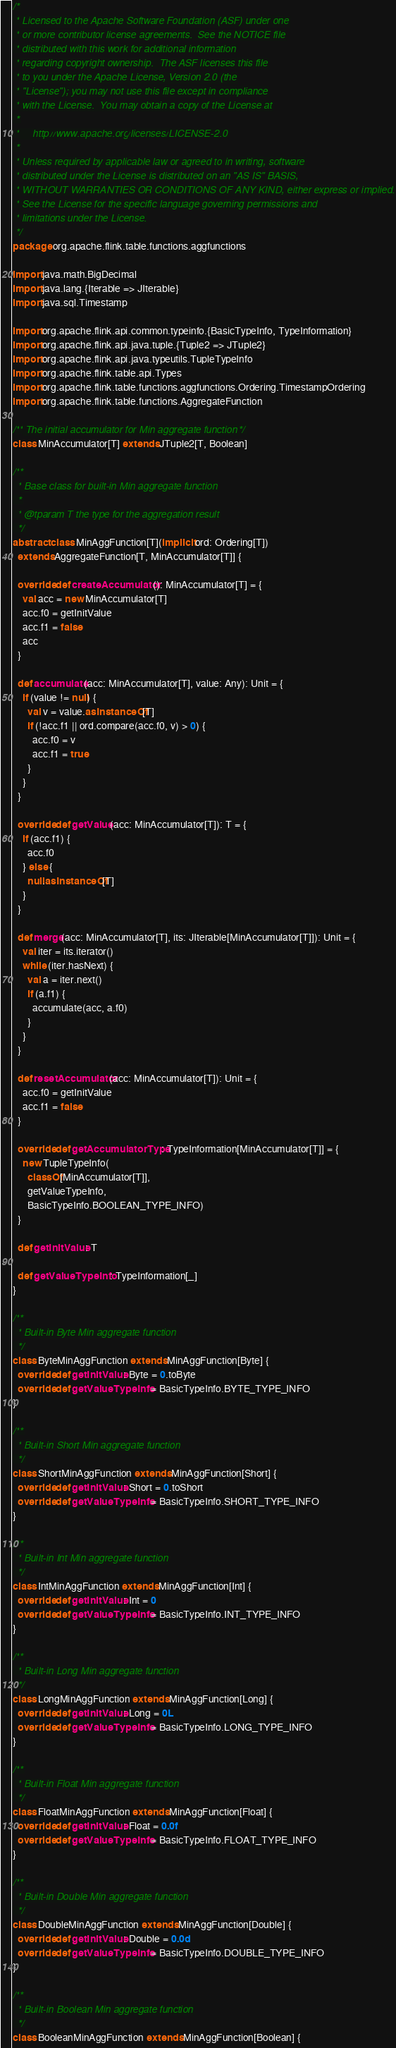Convert code to text. <code><loc_0><loc_0><loc_500><loc_500><_Scala_>/*
 * Licensed to the Apache Software Foundation (ASF) under one
 * or more contributor license agreements.  See the NOTICE file
 * distributed with this work for additional information
 * regarding copyright ownership.  The ASF licenses this file
 * to you under the Apache License, Version 2.0 (the
 * "License"); you may not use this file except in compliance
 * with the License.  You may obtain a copy of the License at
 *
 *     http://www.apache.org/licenses/LICENSE-2.0
 *
 * Unless required by applicable law or agreed to in writing, software
 * distributed under the License is distributed on an "AS IS" BASIS,
 * WITHOUT WARRANTIES OR CONDITIONS OF ANY KIND, either express or implied.
 * See the License for the specific language governing permissions and
 * limitations under the License.
 */
package org.apache.flink.table.functions.aggfunctions

import java.math.BigDecimal
import java.lang.{Iterable => JIterable}
import java.sql.Timestamp

import org.apache.flink.api.common.typeinfo.{BasicTypeInfo, TypeInformation}
import org.apache.flink.api.java.tuple.{Tuple2 => JTuple2}
import org.apache.flink.api.java.typeutils.TupleTypeInfo
import org.apache.flink.table.api.Types
import org.apache.flink.table.functions.aggfunctions.Ordering.TimestampOrdering
import org.apache.flink.table.functions.AggregateFunction

/** The initial accumulator for Min aggregate function */
class MinAccumulator[T] extends JTuple2[T, Boolean]

/**
  * Base class for built-in Min aggregate function
  *
  * @tparam T the type for the aggregation result
  */
abstract class MinAggFunction[T](implicit ord: Ordering[T])
  extends AggregateFunction[T, MinAccumulator[T]] {

  override def createAccumulator(): MinAccumulator[T] = {
    val acc = new MinAccumulator[T]
    acc.f0 = getInitValue
    acc.f1 = false
    acc
  }

  def accumulate(acc: MinAccumulator[T], value: Any): Unit = {
    if (value != null) {
      val v = value.asInstanceOf[T]
      if (!acc.f1 || ord.compare(acc.f0, v) > 0) {
        acc.f0 = v
        acc.f1 = true
      }
    }
  }

  override def getValue(acc: MinAccumulator[T]): T = {
    if (acc.f1) {
      acc.f0
    } else {
      null.asInstanceOf[T]
    }
  }

  def merge(acc: MinAccumulator[T], its: JIterable[MinAccumulator[T]]): Unit = {
    val iter = its.iterator()
    while (iter.hasNext) {
      val a = iter.next()
      if (a.f1) {
        accumulate(acc, a.f0)
      }
    }
  }

  def resetAccumulator(acc: MinAccumulator[T]): Unit = {
    acc.f0 = getInitValue
    acc.f1 = false
  }

  override def getAccumulatorType: TypeInformation[MinAccumulator[T]] = {
    new TupleTypeInfo(
      classOf[MinAccumulator[T]],
      getValueTypeInfo,
      BasicTypeInfo.BOOLEAN_TYPE_INFO)
  }

  def getInitValue: T

  def getValueTypeInfo: TypeInformation[_]
}

/**
  * Built-in Byte Min aggregate function
  */
class ByteMinAggFunction extends MinAggFunction[Byte] {
  override def getInitValue: Byte = 0.toByte
  override def getValueTypeInfo = BasicTypeInfo.BYTE_TYPE_INFO
}

/**
  * Built-in Short Min aggregate function
  */
class ShortMinAggFunction extends MinAggFunction[Short] {
  override def getInitValue: Short = 0.toShort
  override def getValueTypeInfo = BasicTypeInfo.SHORT_TYPE_INFO
}

/**
  * Built-in Int Min aggregate function
  */
class IntMinAggFunction extends MinAggFunction[Int] {
  override def getInitValue: Int = 0
  override def getValueTypeInfo = BasicTypeInfo.INT_TYPE_INFO
}

/**
  * Built-in Long Min aggregate function
  */
class LongMinAggFunction extends MinAggFunction[Long] {
  override def getInitValue: Long = 0L
  override def getValueTypeInfo = BasicTypeInfo.LONG_TYPE_INFO
}

/**
  * Built-in Float Min aggregate function
  */
class FloatMinAggFunction extends MinAggFunction[Float] {
  override def getInitValue: Float = 0.0f
  override def getValueTypeInfo = BasicTypeInfo.FLOAT_TYPE_INFO
}

/**
  * Built-in Double Min aggregate function
  */
class DoubleMinAggFunction extends MinAggFunction[Double] {
  override def getInitValue: Double = 0.0d
  override def getValueTypeInfo = BasicTypeInfo.DOUBLE_TYPE_INFO
}

/**
  * Built-in Boolean Min aggregate function
  */
class BooleanMinAggFunction extends MinAggFunction[Boolean] {</code> 